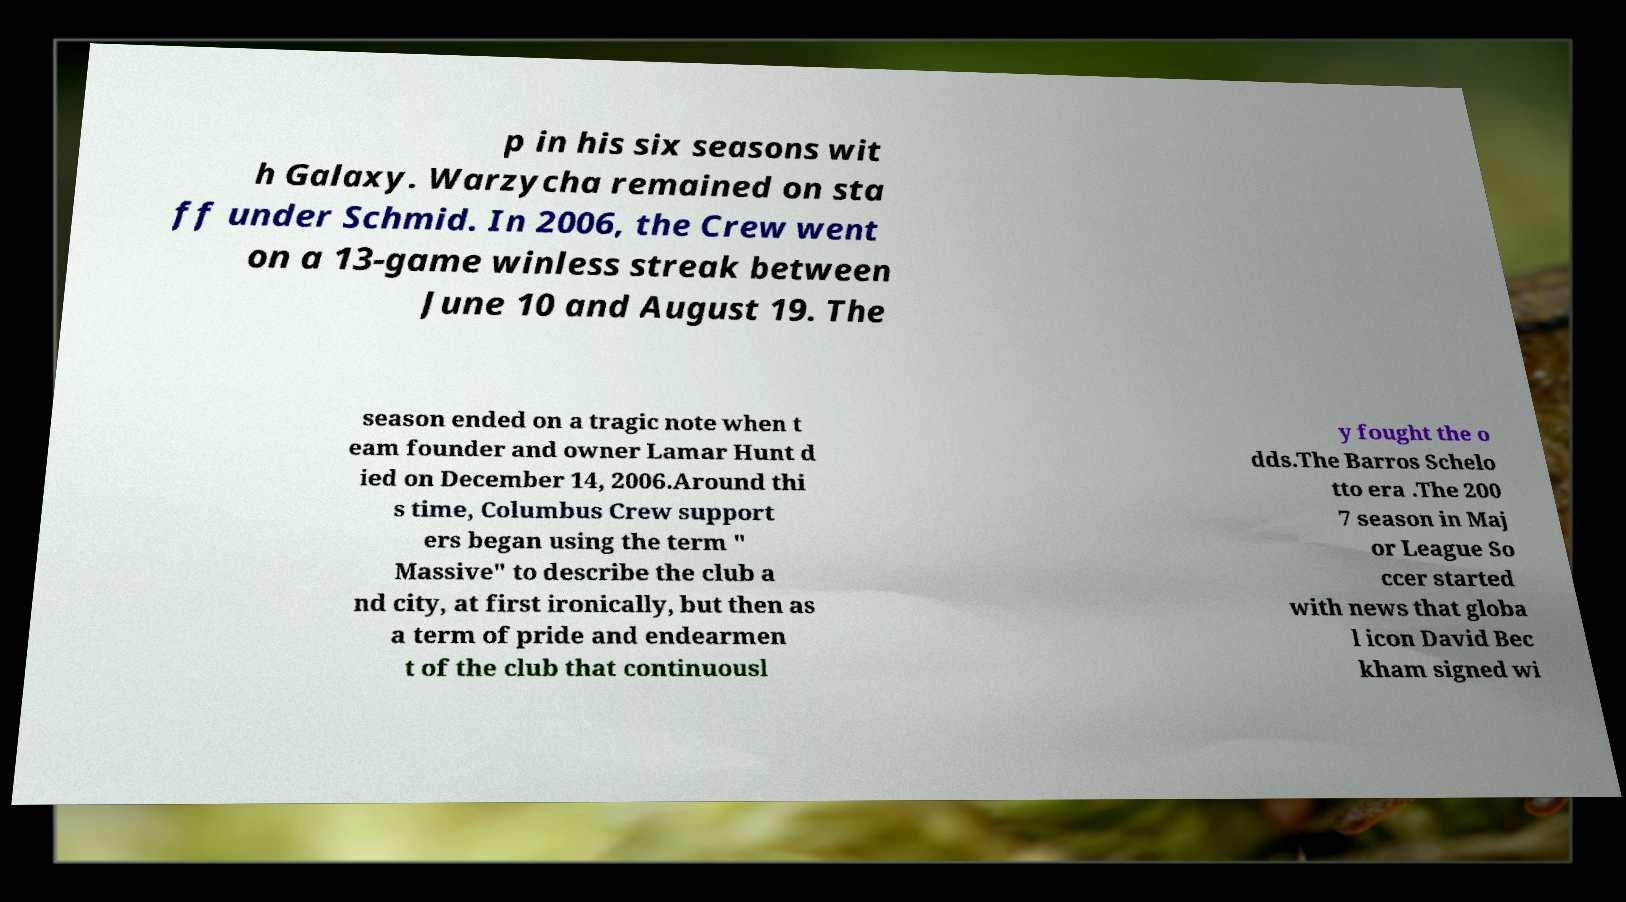What messages or text are displayed in this image? I need them in a readable, typed format. p in his six seasons wit h Galaxy. Warzycha remained on sta ff under Schmid. In 2006, the Crew went on a 13-game winless streak between June 10 and August 19. The season ended on a tragic note when t eam founder and owner Lamar Hunt d ied on December 14, 2006.Around thi s time, Columbus Crew support ers began using the term " Massive" to describe the club a nd city, at first ironically, but then as a term of pride and endearmen t of the club that continuousl y fought the o dds.The Barros Schelo tto era .The 200 7 season in Maj or League So ccer started with news that globa l icon David Bec kham signed wi 